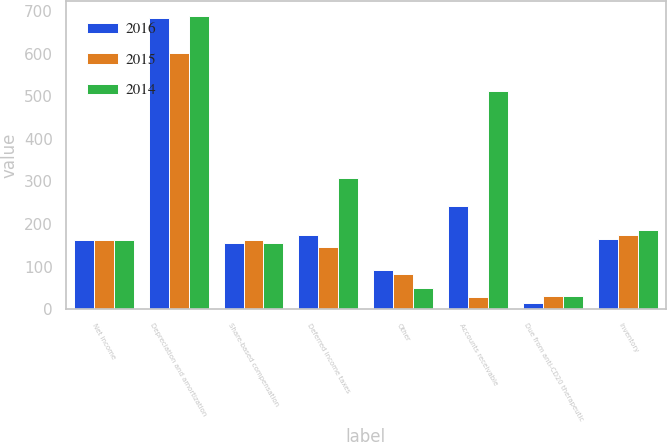<chart> <loc_0><loc_0><loc_500><loc_500><stacked_bar_chart><ecel><fcel>Net income<fcel>Depreciation and amortization<fcel>Share-based compensation<fcel>Deferred income taxes<fcel>Other<fcel>Accounts receivable<fcel>Due from anti-CD20 therapeutic<fcel>Inventory<nl><fcel>2016<fcel>161.4<fcel>682.7<fcel>154.8<fcel>175<fcel>91.2<fcel>241.4<fcel>13.9<fcel>165.6<nl><fcel>2015<fcel>161.4<fcel>600.4<fcel>161.4<fcel>145.6<fcel>82.2<fcel>29<fcel>31.1<fcel>174.4<nl><fcel>2014<fcel>161.4<fcel>688.1<fcel>155.3<fcel>308.2<fcel>50.3<fcel>512.4<fcel>30.7<fcel>185.9<nl></chart> 